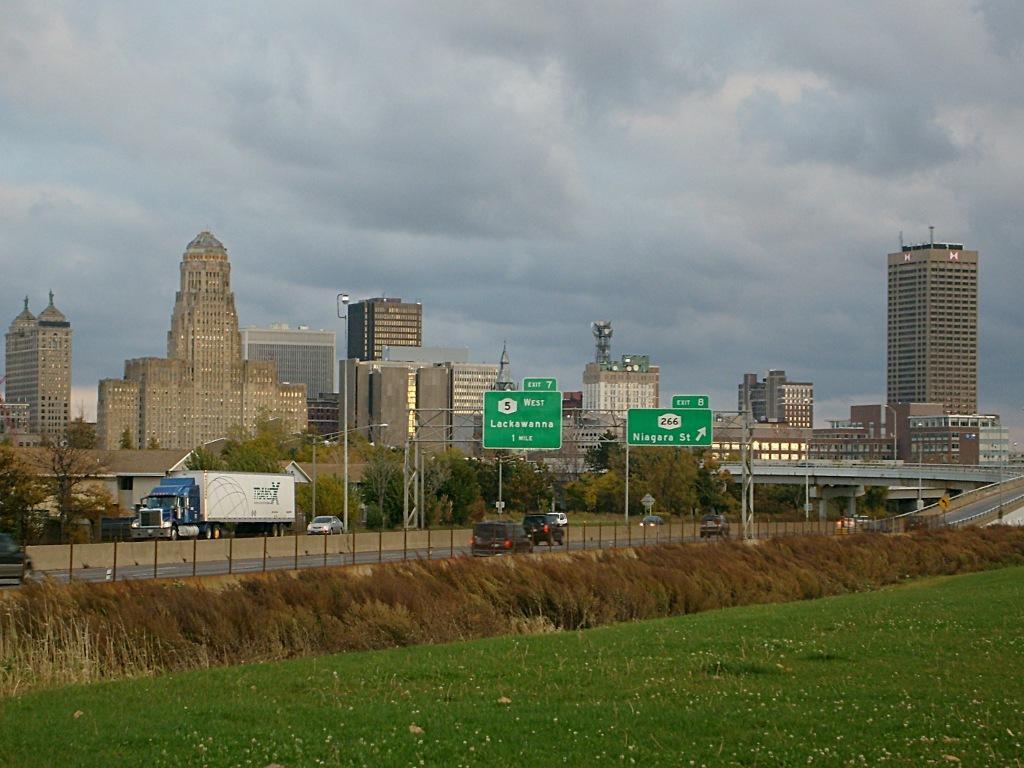In one or two sentences, can you explain what this image depicts? In this picture I can see there are few vehicles moving on the road and there are a few poles with banners, there are trees, buildings in the backdrop with windows and the sky is clear. 